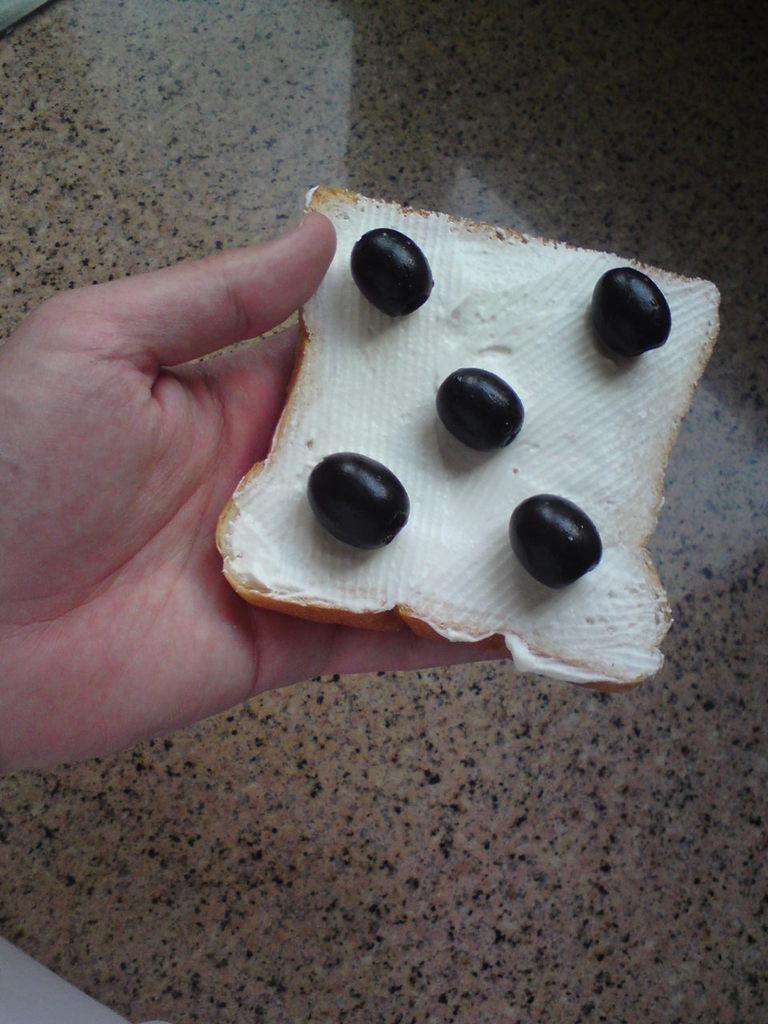What is the person in the image holding? The person is holding a bread slice. What is on the bread slice? There is cream applied on the bread, and berries are on the cream. What can be seen in the background of the image? The background of the image includes a floor. What type of noise can be heard coming from the bread in the image? There is no noise coming from the bread in the image. 